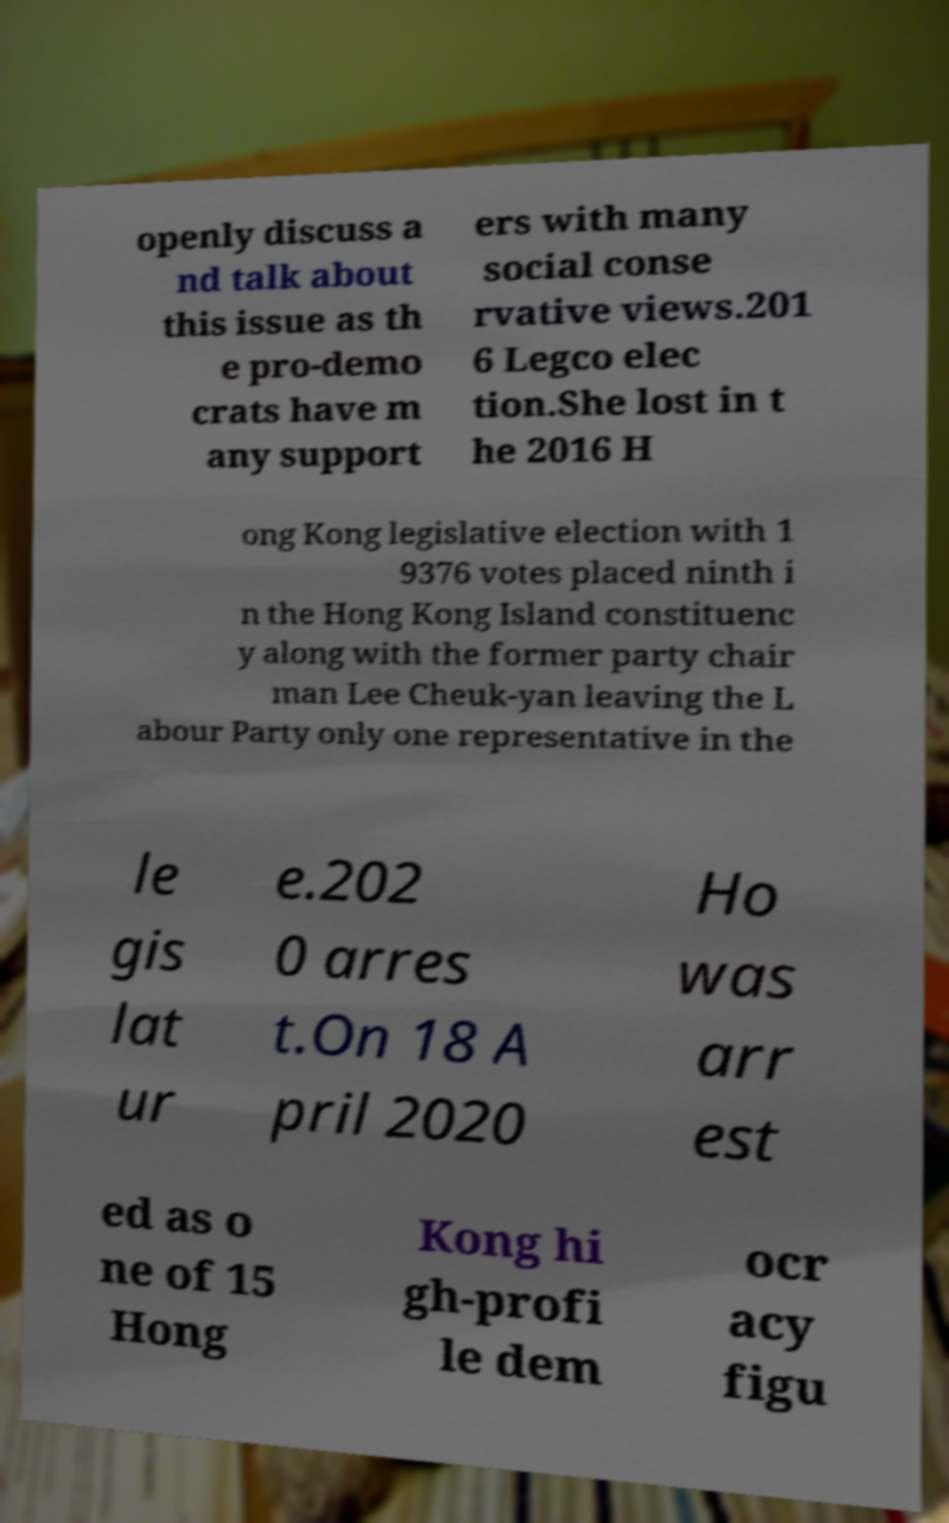Could you extract and type out the text from this image? openly discuss a nd talk about this issue as th e pro-demo crats have m any support ers with many social conse rvative views.201 6 Legco elec tion.She lost in t he 2016 H ong Kong legislative election with 1 9376 votes placed ninth i n the Hong Kong Island constituenc y along with the former party chair man Lee Cheuk-yan leaving the L abour Party only one representative in the le gis lat ur e.202 0 arres t.On 18 A pril 2020 Ho was arr est ed as o ne of 15 Hong Kong hi gh-profi le dem ocr acy figu 